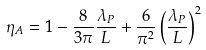<formula> <loc_0><loc_0><loc_500><loc_500>\eta _ { A } = 1 - \frac { 8 } { 3 \pi } \frac { \lambda _ { P } } { L } + \frac { 6 } { \pi ^ { 2 } } \left ( \frac { \lambda _ { P } } { L } \right ) ^ { 2 }</formula> 